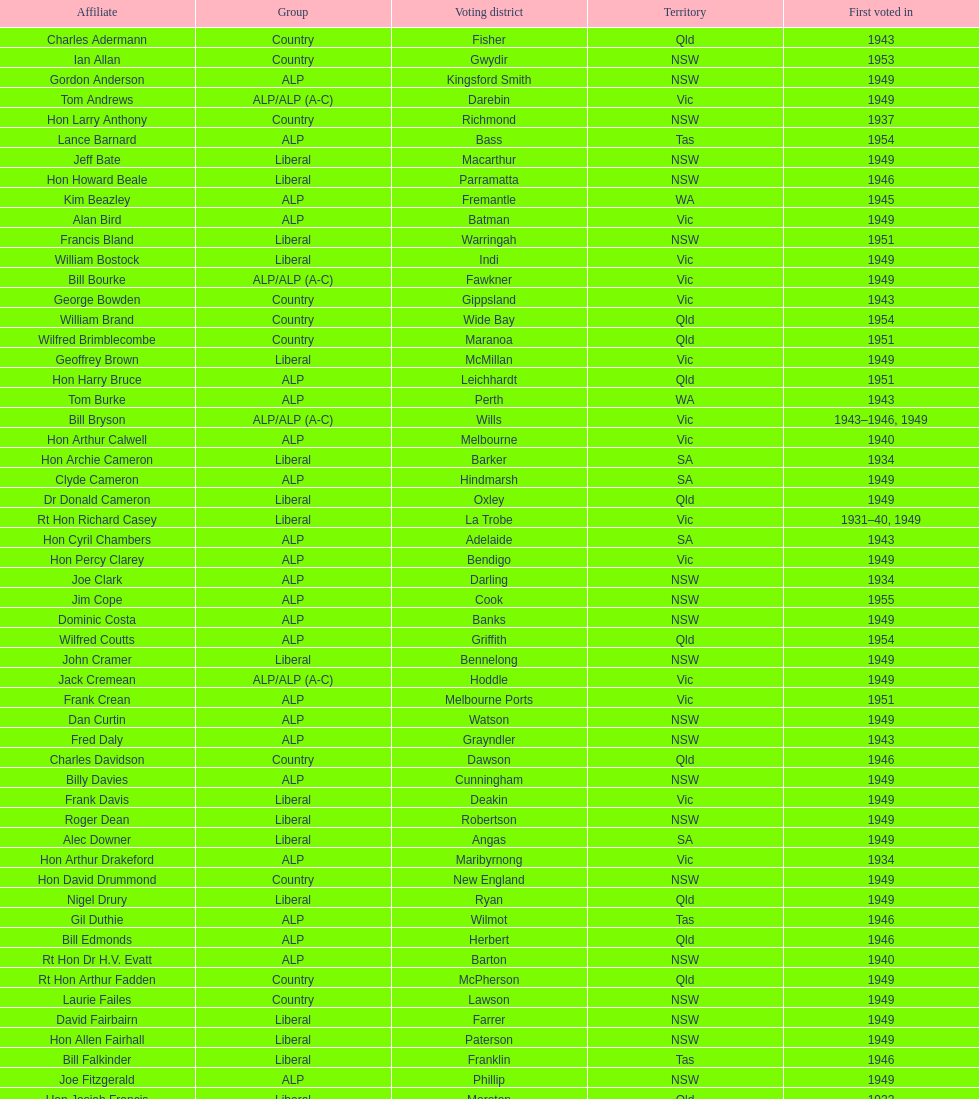Did tom burke run as country or alp party? ALP. 